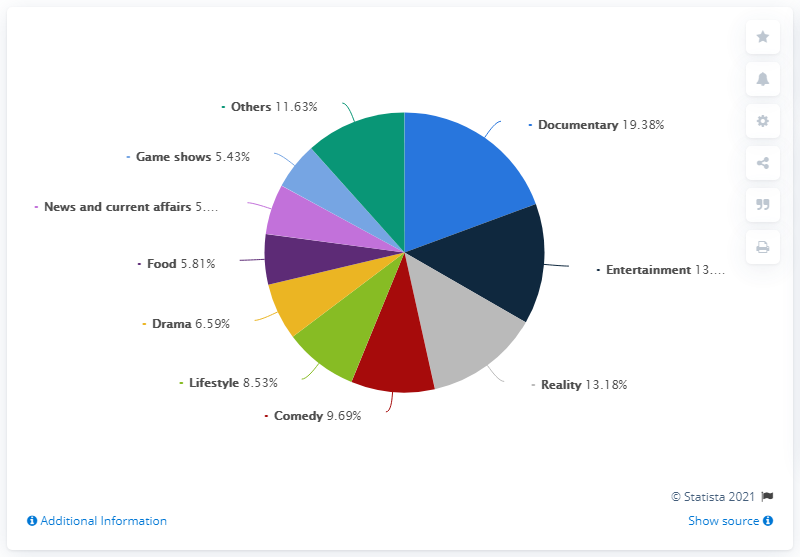Which genre accounts for the largest portion of the chart? The genre that accounts for the largest portion of the chart is 'Documentary,' comprising 19.38% of the total. 